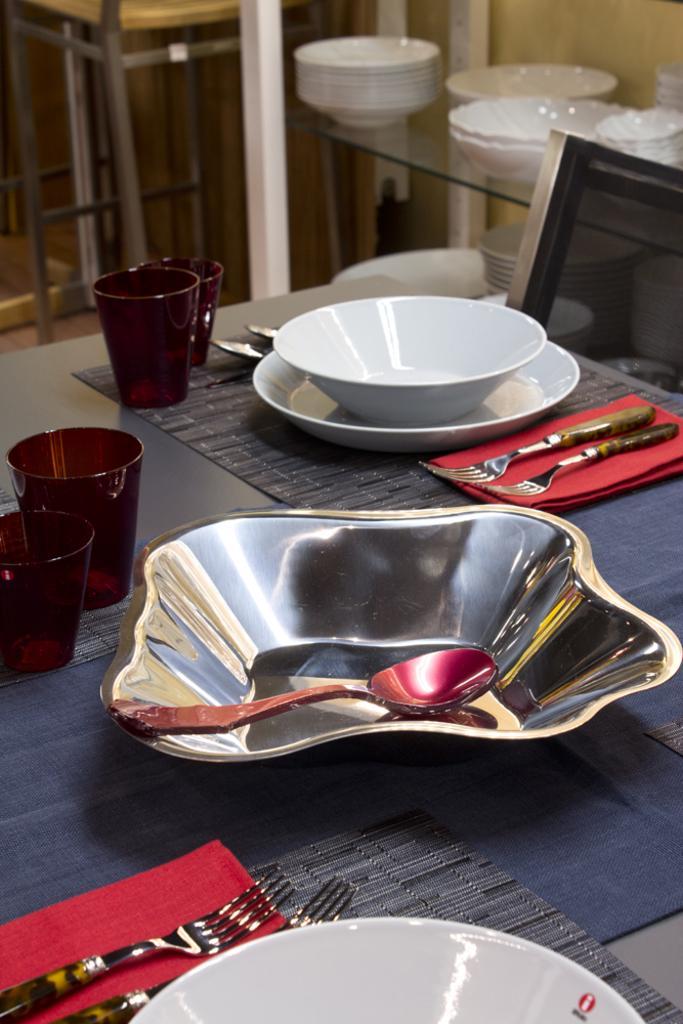Can you describe this image briefly? In the image we can see there is a bowl in a which there is a spoon and the glasses and there is a bowl in a plate and two forks on the cloth. 